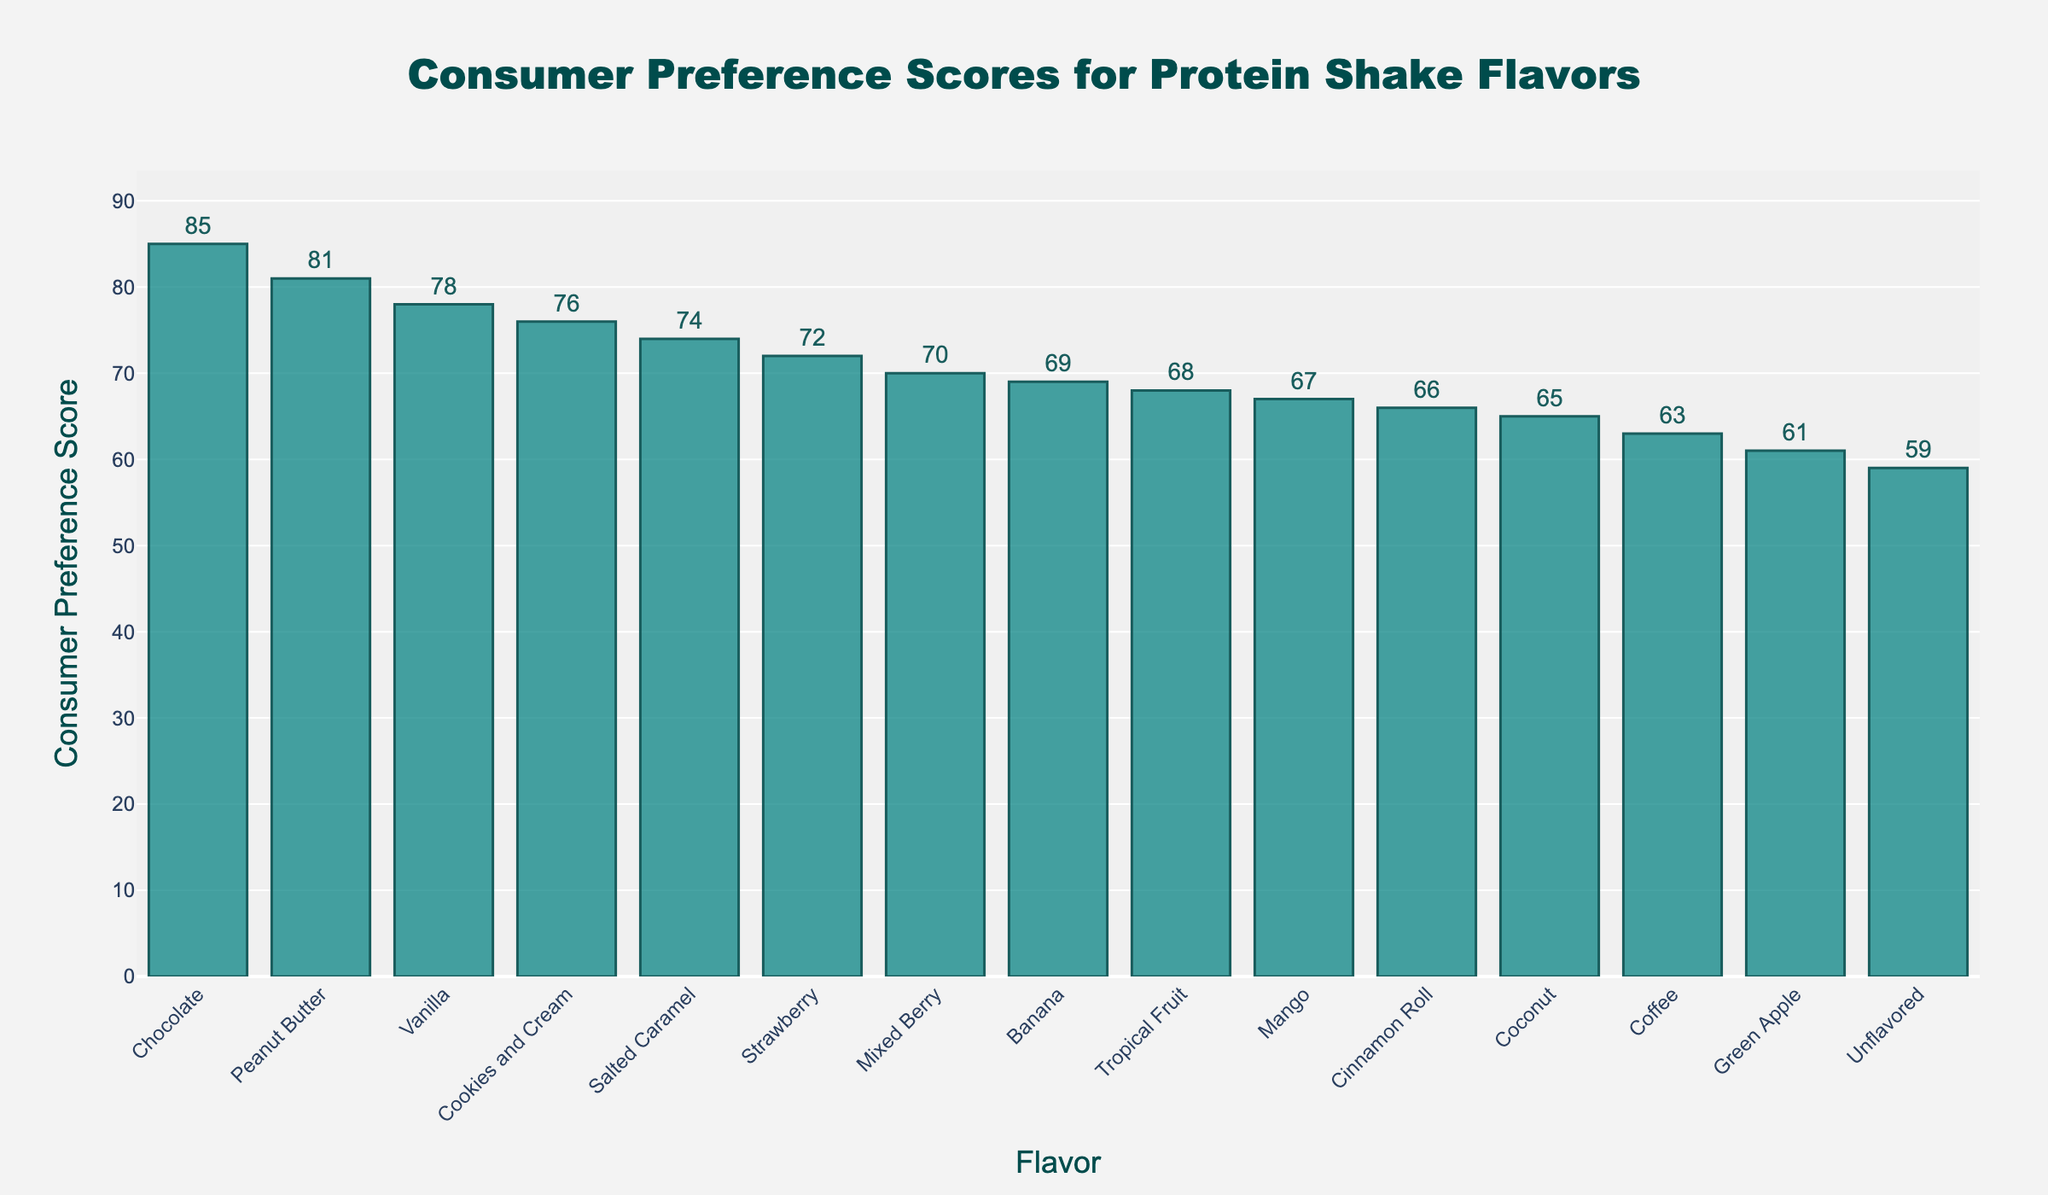Which protein shake flavor has the highest consumer preference score? The bar representing Chocolate is the tallest and has the highest value on the y-axis among all flavors.
Answer: Chocolate What is the consumer preference score for Coffee? Look for the bar labeled Coffee and check its corresponding value on the y-axis.
Answer: 63 How many flavors have a consumer preference score greater than 70? Identify bars with values higher than 70 by checking their y-axis values. The flavors are Vanilla (78), Chocolate (85), Strawberry (72), Peanut Butter (81), and Cookies and Cream (76).
Answer: 5 Which flavor has a lower consumer preference score: Mango or Tropical Fruit? Locate the bars for Mango and Tropical Fruit and compare their heights or y-axis values. Mango has a score of 67, while Tropical Fruit has 68.
Answer: Mango What is the average consumer preference score of Vanilla, Strawberry, and Banana? Add the consumer preference scores of Vanilla (78), Strawberry (72), and Banana (69) and then divide by 3. (78 + 72 + 69) / 3 = 73
Answer: 73 Among the least preferred flavors, which one has a slightly higher score: Coconut or Cinnamon Roll? Check the bars for Coconut and Cinnamon Roll and compare their y-axis values. Coconut has a score of 65, while Cinnamon Roll has 66.
Answer: Cinnamon Roll Which two flavors have the closest consumer preference scores? By comparing the bars, identify which pairs have the smallest difference in heights or y-axis values. Green Apple (61) and Unflavored (59) are closest, differing by 2 points.
Answer: Green Apple and Unflavored What is the total preference score of the top three preferred flavors? Sum the scores of Chocolate (85), Peanut Butter (81), and Vanilla (78). 85 + 81 + 78 = 244
Answer: 244 Which bar is the tallest and what visual characteristics help identify it? The bar for Chocolate is the tallest. It is the tallest because its height extends the farthest up the y-axis and it visually stands out compared to the others.
Answer: Chocolate How much higher is the consumer preference score of Chocolate compared to Unflavored? Subtract the score of Unflavored (59) from Chocolate (85). 85 - 59 = 26
Answer: 26 